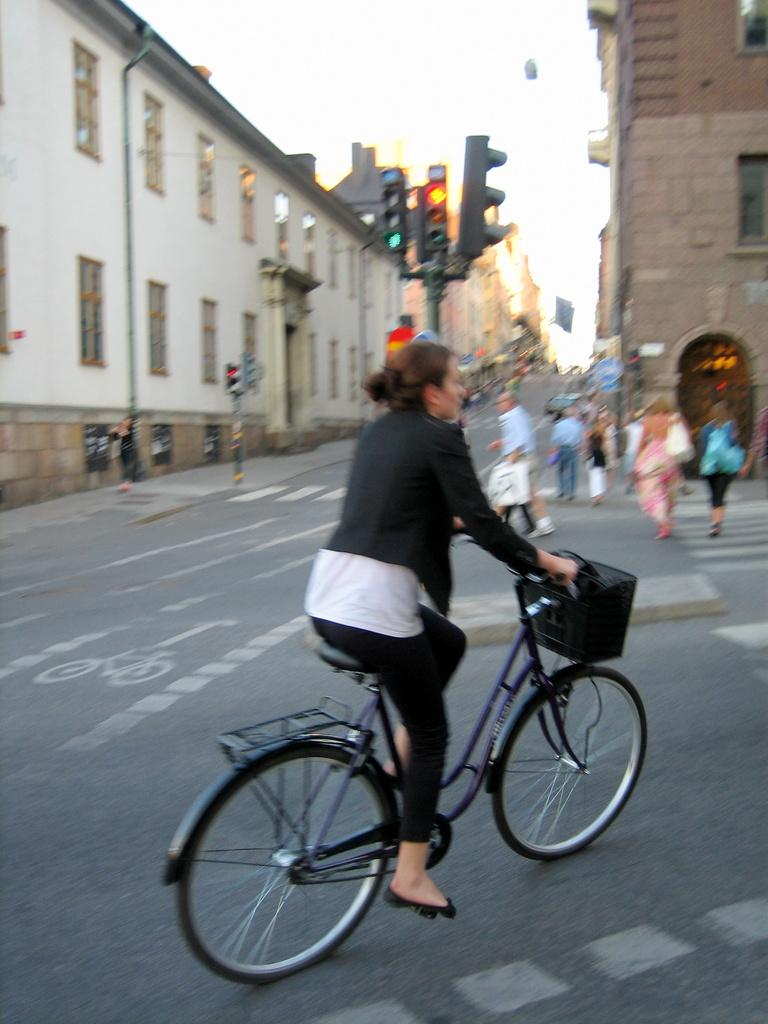What are the people in the image doing? There is a group of people walking on the road in the image. What is the woman in the image doing? The woman is cycling on the road in the image. What can be seen in the background of the image? There are buildings visible in the image. What is used to control traffic in the image? There is a traffic light in the image. What type of pan is being used to cook food in the image? There is no pan or cooking activity present in the image. How many cherries are on the tree in the image? There is no tree or cherries present in the image. 